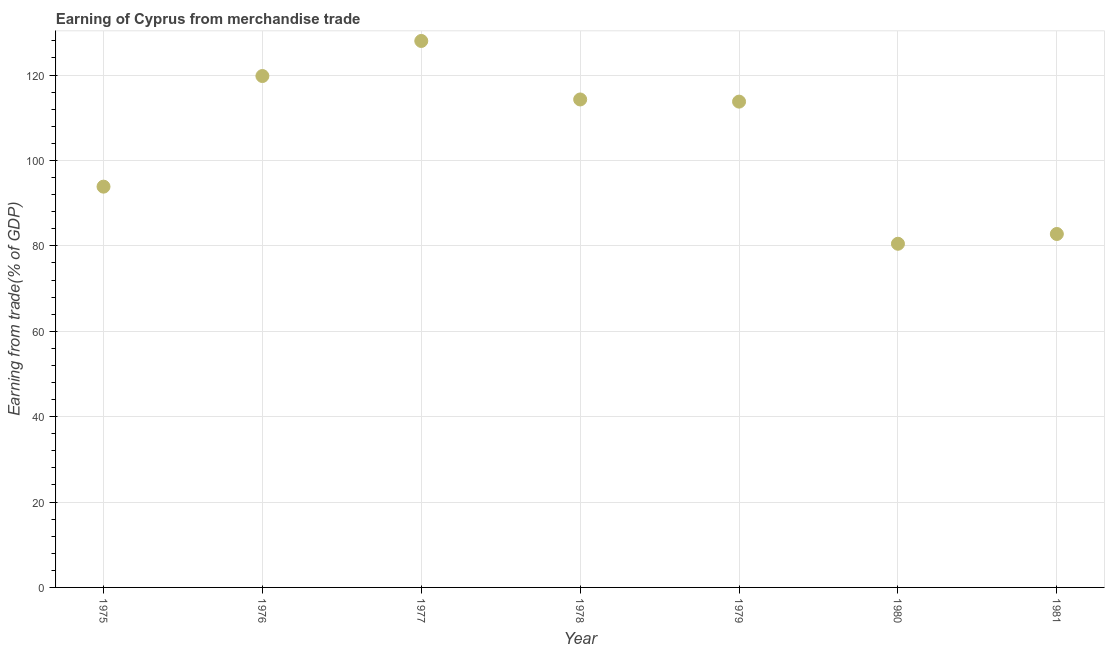What is the earning from merchandise trade in 1976?
Your answer should be compact. 119.77. Across all years, what is the maximum earning from merchandise trade?
Keep it short and to the point. 127.99. Across all years, what is the minimum earning from merchandise trade?
Your answer should be very brief. 80.49. In which year was the earning from merchandise trade maximum?
Give a very brief answer. 1977. What is the sum of the earning from merchandise trade?
Offer a terse response. 732.95. What is the difference between the earning from merchandise trade in 1976 and 1980?
Give a very brief answer. 39.28. What is the average earning from merchandise trade per year?
Your answer should be compact. 104.71. What is the median earning from merchandise trade?
Provide a short and direct response. 113.78. In how many years, is the earning from merchandise trade greater than 88 %?
Ensure brevity in your answer.  5. Do a majority of the years between 1977 and 1980 (inclusive) have earning from merchandise trade greater than 112 %?
Provide a succinct answer. Yes. What is the ratio of the earning from merchandise trade in 1975 to that in 1977?
Your answer should be very brief. 0.73. Is the earning from merchandise trade in 1975 less than that in 1979?
Offer a terse response. Yes. Is the difference between the earning from merchandise trade in 1978 and 1979 greater than the difference between any two years?
Your response must be concise. No. What is the difference between the highest and the second highest earning from merchandise trade?
Your answer should be compact. 8.21. Is the sum of the earning from merchandise trade in 1975 and 1980 greater than the maximum earning from merchandise trade across all years?
Your response must be concise. Yes. What is the difference between the highest and the lowest earning from merchandise trade?
Offer a very short reply. 47.5. In how many years, is the earning from merchandise trade greater than the average earning from merchandise trade taken over all years?
Give a very brief answer. 4. What is the difference between two consecutive major ticks on the Y-axis?
Provide a short and direct response. 20. Are the values on the major ticks of Y-axis written in scientific E-notation?
Your answer should be compact. No. Does the graph contain grids?
Provide a short and direct response. Yes. What is the title of the graph?
Provide a succinct answer. Earning of Cyprus from merchandise trade. What is the label or title of the X-axis?
Provide a succinct answer. Year. What is the label or title of the Y-axis?
Provide a succinct answer. Earning from trade(% of GDP). What is the Earning from trade(% of GDP) in 1975?
Give a very brief answer. 93.86. What is the Earning from trade(% of GDP) in 1976?
Your answer should be compact. 119.77. What is the Earning from trade(% of GDP) in 1977?
Provide a succinct answer. 127.99. What is the Earning from trade(% of GDP) in 1978?
Offer a terse response. 114.28. What is the Earning from trade(% of GDP) in 1979?
Offer a terse response. 113.78. What is the Earning from trade(% of GDP) in 1980?
Your response must be concise. 80.49. What is the Earning from trade(% of GDP) in 1981?
Keep it short and to the point. 82.78. What is the difference between the Earning from trade(% of GDP) in 1975 and 1976?
Give a very brief answer. -25.91. What is the difference between the Earning from trade(% of GDP) in 1975 and 1977?
Provide a short and direct response. -34.12. What is the difference between the Earning from trade(% of GDP) in 1975 and 1978?
Make the answer very short. -20.42. What is the difference between the Earning from trade(% of GDP) in 1975 and 1979?
Your answer should be very brief. -19.91. What is the difference between the Earning from trade(% of GDP) in 1975 and 1980?
Give a very brief answer. 13.37. What is the difference between the Earning from trade(% of GDP) in 1975 and 1981?
Provide a succinct answer. 11.09. What is the difference between the Earning from trade(% of GDP) in 1976 and 1977?
Provide a succinct answer. -8.21. What is the difference between the Earning from trade(% of GDP) in 1976 and 1978?
Ensure brevity in your answer.  5.49. What is the difference between the Earning from trade(% of GDP) in 1976 and 1979?
Offer a very short reply. 6. What is the difference between the Earning from trade(% of GDP) in 1976 and 1980?
Keep it short and to the point. 39.28. What is the difference between the Earning from trade(% of GDP) in 1976 and 1981?
Your answer should be compact. 36.99. What is the difference between the Earning from trade(% of GDP) in 1977 and 1978?
Your answer should be compact. 13.7. What is the difference between the Earning from trade(% of GDP) in 1977 and 1979?
Keep it short and to the point. 14.21. What is the difference between the Earning from trade(% of GDP) in 1977 and 1980?
Ensure brevity in your answer.  47.5. What is the difference between the Earning from trade(% of GDP) in 1977 and 1981?
Provide a short and direct response. 45.21. What is the difference between the Earning from trade(% of GDP) in 1978 and 1979?
Give a very brief answer. 0.51. What is the difference between the Earning from trade(% of GDP) in 1978 and 1980?
Provide a short and direct response. 33.79. What is the difference between the Earning from trade(% of GDP) in 1978 and 1981?
Your answer should be compact. 31.51. What is the difference between the Earning from trade(% of GDP) in 1979 and 1980?
Your answer should be compact. 33.29. What is the difference between the Earning from trade(% of GDP) in 1979 and 1981?
Give a very brief answer. 31. What is the difference between the Earning from trade(% of GDP) in 1980 and 1981?
Your answer should be compact. -2.29. What is the ratio of the Earning from trade(% of GDP) in 1975 to that in 1976?
Your response must be concise. 0.78. What is the ratio of the Earning from trade(% of GDP) in 1975 to that in 1977?
Keep it short and to the point. 0.73. What is the ratio of the Earning from trade(% of GDP) in 1975 to that in 1978?
Offer a very short reply. 0.82. What is the ratio of the Earning from trade(% of GDP) in 1975 to that in 1979?
Your answer should be very brief. 0.82. What is the ratio of the Earning from trade(% of GDP) in 1975 to that in 1980?
Your answer should be compact. 1.17. What is the ratio of the Earning from trade(% of GDP) in 1975 to that in 1981?
Keep it short and to the point. 1.13. What is the ratio of the Earning from trade(% of GDP) in 1976 to that in 1977?
Ensure brevity in your answer.  0.94. What is the ratio of the Earning from trade(% of GDP) in 1976 to that in 1978?
Your answer should be very brief. 1.05. What is the ratio of the Earning from trade(% of GDP) in 1976 to that in 1979?
Keep it short and to the point. 1.05. What is the ratio of the Earning from trade(% of GDP) in 1976 to that in 1980?
Offer a very short reply. 1.49. What is the ratio of the Earning from trade(% of GDP) in 1976 to that in 1981?
Offer a terse response. 1.45. What is the ratio of the Earning from trade(% of GDP) in 1977 to that in 1978?
Give a very brief answer. 1.12. What is the ratio of the Earning from trade(% of GDP) in 1977 to that in 1980?
Offer a terse response. 1.59. What is the ratio of the Earning from trade(% of GDP) in 1977 to that in 1981?
Your response must be concise. 1.55. What is the ratio of the Earning from trade(% of GDP) in 1978 to that in 1980?
Offer a very short reply. 1.42. What is the ratio of the Earning from trade(% of GDP) in 1978 to that in 1981?
Provide a short and direct response. 1.38. What is the ratio of the Earning from trade(% of GDP) in 1979 to that in 1980?
Make the answer very short. 1.41. What is the ratio of the Earning from trade(% of GDP) in 1979 to that in 1981?
Your answer should be compact. 1.37. What is the ratio of the Earning from trade(% of GDP) in 1980 to that in 1981?
Make the answer very short. 0.97. 